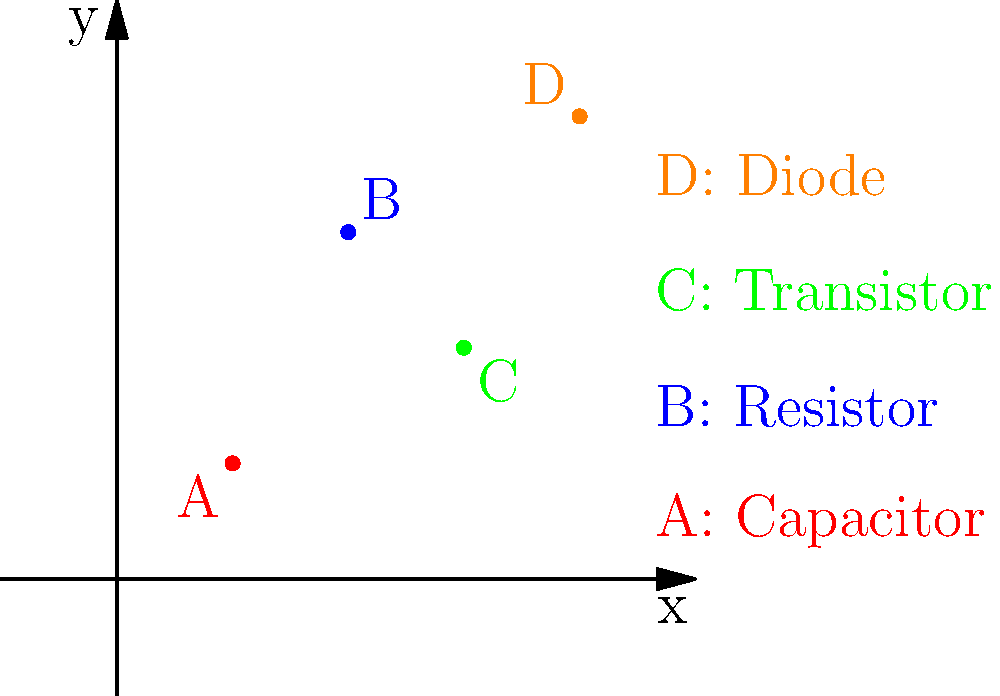In the context of cross-cultural communication in electrical engineering, analyze the graph representing the prevalence of different electronic components in various global regions. Which component, represented by point B, is most commonly found in electronic devices across diverse cultural contexts, and why might this be significant for a cultural anthropologist studying technological adaptations? To answer this question, let's analyze the graph step-by-step:

1. The graph shows four points (A, B, C, and D) representing different electronic components plotted on a coordinate system.

2. Each point's position on the graph likely represents its prevalence or importance in electronic devices across different global regions.

3. Point B, representing a resistor, is positioned at (2,3), which is higher on the y-axis compared to other components.

4. In electrical engineering, resistors are fundamental components used in virtually all electronic circuits for controlling current flow and voltage levels.

5. From a cultural anthropologist's perspective, the widespread use of resistors (Point B) across diverse cultural contexts is significant because:

   a) It indicates a level of technological standardization across different cultures.
   b) It suggests that basic principles of electrical engineering are universally applied, transcending cultural boundaries.
   c) The prevalence of resistors might reflect shared challenges or needs in electronic device design across various societies.
   d) Understanding the ubiquity of certain components can provide insights into how different cultures adapt and integrate technology.

6. This information can be valuable for a cultural anthropologist studying:
   - The diffusion of technological knowledge across cultures
   - The impact of globalization on technological practices
   - How different societies approach problem-solving in electronics
   - The potential for cross-cultural collaboration in technological fields

7. The prevalence of resistors also hints at a common technological language that could facilitate cross-cultural communication in the field of electrical engineering.
Answer: Resistor; universal in circuit design, indicating technological standardization across cultures. 